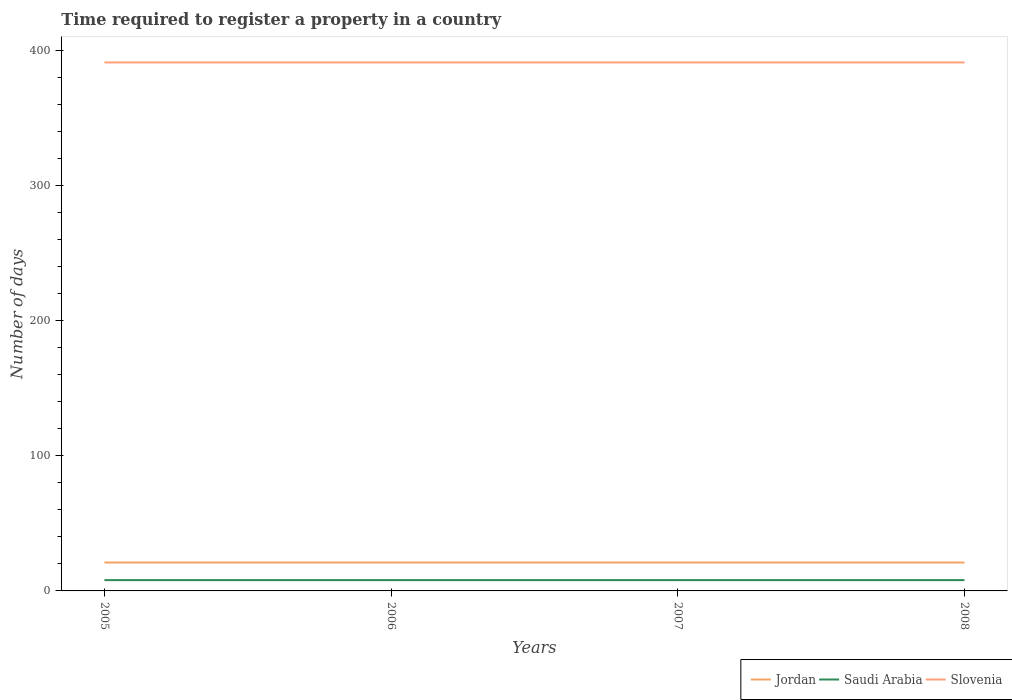How many different coloured lines are there?
Make the answer very short. 3. Across all years, what is the maximum number of days required to register a property in Saudi Arabia?
Your answer should be very brief. 8. In which year was the number of days required to register a property in Saudi Arabia maximum?
Give a very brief answer. 2005. What is the difference between the highest and the lowest number of days required to register a property in Slovenia?
Give a very brief answer. 0. How many lines are there?
Provide a short and direct response. 3. What is the difference between two consecutive major ticks on the Y-axis?
Keep it short and to the point. 100. Are the values on the major ticks of Y-axis written in scientific E-notation?
Make the answer very short. No. Does the graph contain any zero values?
Your answer should be very brief. No. Where does the legend appear in the graph?
Offer a terse response. Bottom right. How are the legend labels stacked?
Make the answer very short. Horizontal. What is the title of the graph?
Provide a short and direct response. Time required to register a property in a country. What is the label or title of the Y-axis?
Your answer should be compact. Number of days. What is the Number of days in Slovenia in 2005?
Your response must be concise. 391. What is the Number of days in Saudi Arabia in 2006?
Offer a very short reply. 8. What is the Number of days in Slovenia in 2006?
Keep it short and to the point. 391. What is the Number of days in Saudi Arabia in 2007?
Ensure brevity in your answer.  8. What is the Number of days in Slovenia in 2007?
Provide a short and direct response. 391. What is the Number of days of Jordan in 2008?
Your response must be concise. 21. What is the Number of days in Slovenia in 2008?
Offer a very short reply. 391. Across all years, what is the maximum Number of days of Slovenia?
Your answer should be very brief. 391. Across all years, what is the minimum Number of days in Slovenia?
Offer a very short reply. 391. What is the total Number of days of Jordan in the graph?
Provide a short and direct response. 84. What is the total Number of days of Slovenia in the graph?
Make the answer very short. 1564. What is the difference between the Number of days of Jordan in 2005 and that in 2006?
Offer a very short reply. 0. What is the difference between the Number of days of Saudi Arabia in 2005 and that in 2007?
Make the answer very short. 0. What is the difference between the Number of days of Saudi Arabia in 2005 and that in 2008?
Ensure brevity in your answer.  0. What is the difference between the Number of days in Jordan in 2006 and that in 2007?
Make the answer very short. 0. What is the difference between the Number of days in Saudi Arabia in 2006 and that in 2007?
Provide a short and direct response. 0. What is the difference between the Number of days in Jordan in 2006 and that in 2008?
Your answer should be very brief. 0. What is the difference between the Number of days in Slovenia in 2006 and that in 2008?
Offer a terse response. 0. What is the difference between the Number of days of Saudi Arabia in 2007 and that in 2008?
Offer a very short reply. 0. What is the difference between the Number of days of Slovenia in 2007 and that in 2008?
Keep it short and to the point. 0. What is the difference between the Number of days of Jordan in 2005 and the Number of days of Slovenia in 2006?
Offer a terse response. -370. What is the difference between the Number of days in Saudi Arabia in 2005 and the Number of days in Slovenia in 2006?
Keep it short and to the point. -383. What is the difference between the Number of days in Jordan in 2005 and the Number of days in Slovenia in 2007?
Provide a succinct answer. -370. What is the difference between the Number of days of Saudi Arabia in 2005 and the Number of days of Slovenia in 2007?
Provide a short and direct response. -383. What is the difference between the Number of days in Jordan in 2005 and the Number of days in Slovenia in 2008?
Your answer should be very brief. -370. What is the difference between the Number of days of Saudi Arabia in 2005 and the Number of days of Slovenia in 2008?
Provide a short and direct response. -383. What is the difference between the Number of days of Jordan in 2006 and the Number of days of Saudi Arabia in 2007?
Provide a short and direct response. 13. What is the difference between the Number of days of Jordan in 2006 and the Number of days of Slovenia in 2007?
Keep it short and to the point. -370. What is the difference between the Number of days of Saudi Arabia in 2006 and the Number of days of Slovenia in 2007?
Ensure brevity in your answer.  -383. What is the difference between the Number of days in Jordan in 2006 and the Number of days in Slovenia in 2008?
Provide a succinct answer. -370. What is the difference between the Number of days of Saudi Arabia in 2006 and the Number of days of Slovenia in 2008?
Offer a terse response. -383. What is the difference between the Number of days of Jordan in 2007 and the Number of days of Slovenia in 2008?
Ensure brevity in your answer.  -370. What is the difference between the Number of days of Saudi Arabia in 2007 and the Number of days of Slovenia in 2008?
Offer a terse response. -383. What is the average Number of days in Jordan per year?
Your answer should be compact. 21. What is the average Number of days in Slovenia per year?
Provide a short and direct response. 391. In the year 2005, what is the difference between the Number of days of Jordan and Number of days of Saudi Arabia?
Provide a short and direct response. 13. In the year 2005, what is the difference between the Number of days of Jordan and Number of days of Slovenia?
Offer a terse response. -370. In the year 2005, what is the difference between the Number of days in Saudi Arabia and Number of days in Slovenia?
Your response must be concise. -383. In the year 2006, what is the difference between the Number of days of Jordan and Number of days of Slovenia?
Ensure brevity in your answer.  -370. In the year 2006, what is the difference between the Number of days of Saudi Arabia and Number of days of Slovenia?
Provide a short and direct response. -383. In the year 2007, what is the difference between the Number of days of Jordan and Number of days of Slovenia?
Ensure brevity in your answer.  -370. In the year 2007, what is the difference between the Number of days of Saudi Arabia and Number of days of Slovenia?
Give a very brief answer. -383. In the year 2008, what is the difference between the Number of days of Jordan and Number of days of Saudi Arabia?
Offer a terse response. 13. In the year 2008, what is the difference between the Number of days in Jordan and Number of days in Slovenia?
Ensure brevity in your answer.  -370. In the year 2008, what is the difference between the Number of days of Saudi Arabia and Number of days of Slovenia?
Provide a succinct answer. -383. What is the ratio of the Number of days in Jordan in 2005 to that in 2007?
Your answer should be very brief. 1. What is the ratio of the Number of days in Slovenia in 2005 to that in 2007?
Your answer should be compact. 1. What is the ratio of the Number of days of Slovenia in 2005 to that in 2008?
Offer a very short reply. 1. What is the ratio of the Number of days of Jordan in 2006 to that in 2007?
Ensure brevity in your answer.  1. What is the ratio of the Number of days in Saudi Arabia in 2006 to that in 2007?
Provide a short and direct response. 1. What is the ratio of the Number of days in Slovenia in 2006 to that in 2007?
Provide a succinct answer. 1. What is the ratio of the Number of days in Jordan in 2006 to that in 2008?
Offer a terse response. 1. What is the ratio of the Number of days in Saudi Arabia in 2006 to that in 2008?
Your answer should be very brief. 1. What is the ratio of the Number of days in Jordan in 2007 to that in 2008?
Offer a terse response. 1. What is the difference between the highest and the second highest Number of days in Jordan?
Provide a succinct answer. 0. What is the difference between the highest and the second highest Number of days in Saudi Arabia?
Provide a short and direct response. 0. What is the difference between the highest and the second highest Number of days of Slovenia?
Keep it short and to the point. 0. What is the difference between the highest and the lowest Number of days in Saudi Arabia?
Offer a very short reply. 0. What is the difference between the highest and the lowest Number of days of Slovenia?
Your answer should be very brief. 0. 